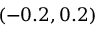<formula> <loc_0><loc_0><loc_500><loc_500>( - 0 . 2 , 0 . 2 )</formula> 